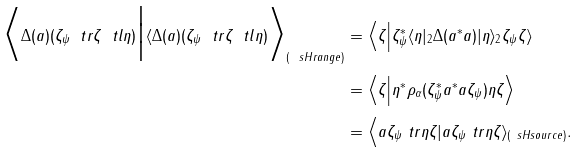Convert formula to latex. <formula><loc_0><loc_0><loc_500><loc_500>\Big \langle \Delta ( a ) ( \zeta _ { \psi } \ t r \zeta \ t l \eta ) \Big | \langle \Delta ( a ) ( \zeta _ { \psi } \ t r \zeta \ t l \eta ) \Big \rangle _ { ( \ s H r a n g e ) } & = \Big \langle \zeta \Big | \zeta _ { \psi } ^ { * } \langle \eta | _ { 2 } \Delta ( a ^ { * } a ) | \eta \rangle _ { 2 } \zeta _ { \psi } \zeta \rangle \\ & = \Big \langle \zeta \Big | \eta ^ { * } \rho _ { \alpha } ( \zeta _ { \psi } ^ { * } a ^ { * } a \zeta _ { \psi } ) \eta \zeta \Big \rangle \\ & = \Big \langle a \zeta _ { \psi } \ t r \eta \zeta | a \zeta _ { \psi } \ t r \eta \zeta \rangle _ { ( \ s H s o u r c e ) } .</formula> 